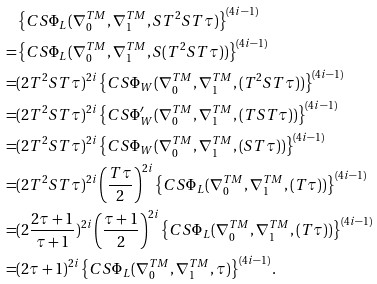Convert formula to latex. <formula><loc_0><loc_0><loc_500><loc_500>& \left \{ C S \Phi _ { L } ( \nabla _ { 0 } ^ { T M } , \nabla _ { 1 } ^ { T M } , S T ^ { 2 } S T \tau ) \right \} ^ { ( 4 i - 1 ) } \\ = & \left \{ C S \Phi _ { L } ( \nabla _ { 0 } ^ { T M } , \nabla _ { 1 } ^ { T M } , S ( T ^ { 2 } S T \tau ) ) \right \} ^ { ( 4 i - 1 ) } \\ = & ( 2 T ^ { 2 } S T \tau ) ^ { 2 i } \left \{ C S \Phi _ { W } ( \nabla _ { 0 } ^ { T M } , \nabla _ { 1 } ^ { T M } , ( T ^ { 2 } S T \tau ) ) \right \} ^ { ( 4 i - 1 ) } \\ = & ( 2 T ^ { 2 } S T \tau ) ^ { 2 i } \left \{ C S \Phi _ { W } ^ { \prime } ( \nabla _ { 0 } ^ { T M } , \nabla _ { 1 } ^ { T M } , ( T S T \tau ) ) \right \} ^ { ( 4 i - 1 ) } \\ = & ( 2 T ^ { 2 } S T \tau ) ^ { 2 i } \left \{ C S \Phi _ { W } ( \nabla _ { 0 } ^ { T M } , \nabla _ { 1 } ^ { T M } , ( S T \tau ) ) \right \} ^ { ( 4 i - 1 ) } \\ = & ( 2 T ^ { 2 } S T \tau ) ^ { 2 i } \left ( \frac { T \tau } { 2 } \right ) ^ { 2 i } \left \{ C S \Phi _ { L } ( \nabla _ { 0 } ^ { T M } , \nabla _ { 1 } ^ { T M } , ( T \tau ) ) \right \} ^ { ( 4 i - 1 ) } \\ = & ( 2 \frac { 2 \tau + 1 } { \tau + 1 } ) ^ { 2 i } \left ( \frac { \tau + 1 } { 2 } \right ) ^ { 2 i } \left \{ C S \Phi _ { L } ( \nabla _ { 0 } ^ { T M } , \nabla _ { 1 } ^ { T M } , ( T \tau ) ) \right \} ^ { ( 4 i - 1 ) } \\ = & ( 2 \tau + 1 ) ^ { 2 i } \left \{ C S \Phi _ { L } ( \nabla _ { 0 } ^ { T M } , \nabla _ { 1 } ^ { T M } , \tau ) \right \} ^ { ( 4 i - 1 ) } .</formula> 